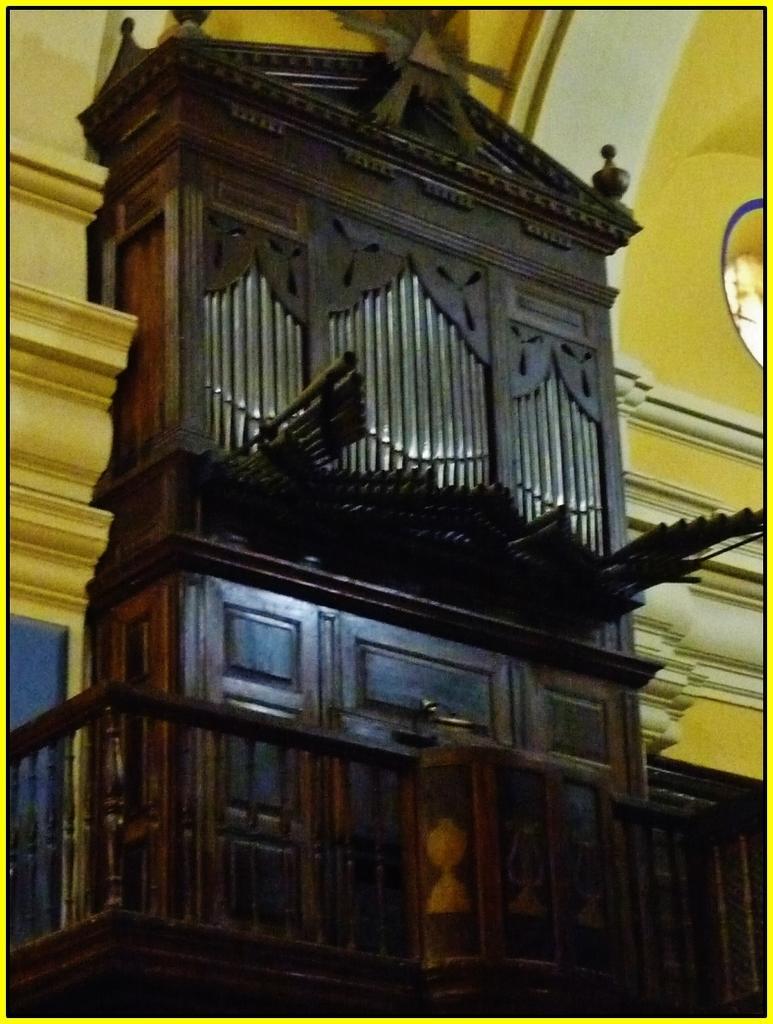Please provide a concise description of this image. In the picture there is a wooden cabinet and behind that there is a wall. 